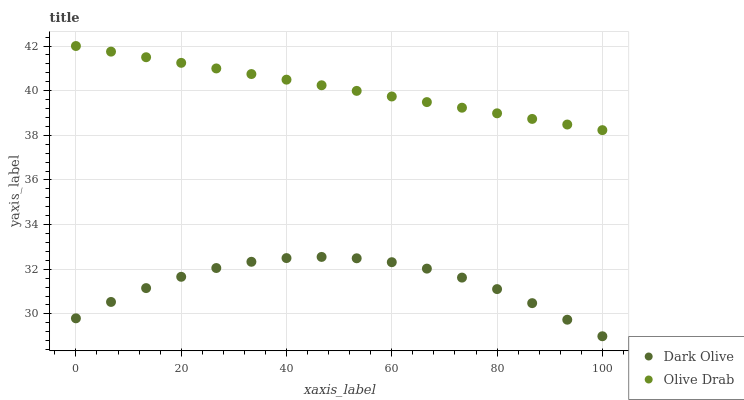Does Dark Olive have the minimum area under the curve?
Answer yes or no. Yes. Does Olive Drab have the maximum area under the curve?
Answer yes or no. Yes. Does Olive Drab have the minimum area under the curve?
Answer yes or no. No. Is Olive Drab the smoothest?
Answer yes or no. Yes. Is Dark Olive the roughest?
Answer yes or no. Yes. Is Olive Drab the roughest?
Answer yes or no. No. Does Dark Olive have the lowest value?
Answer yes or no. Yes. Does Olive Drab have the lowest value?
Answer yes or no. No. Does Olive Drab have the highest value?
Answer yes or no. Yes. Is Dark Olive less than Olive Drab?
Answer yes or no. Yes. Is Olive Drab greater than Dark Olive?
Answer yes or no. Yes. Does Dark Olive intersect Olive Drab?
Answer yes or no. No. 